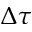<formula> <loc_0><loc_0><loc_500><loc_500>\Delta \tau</formula> 